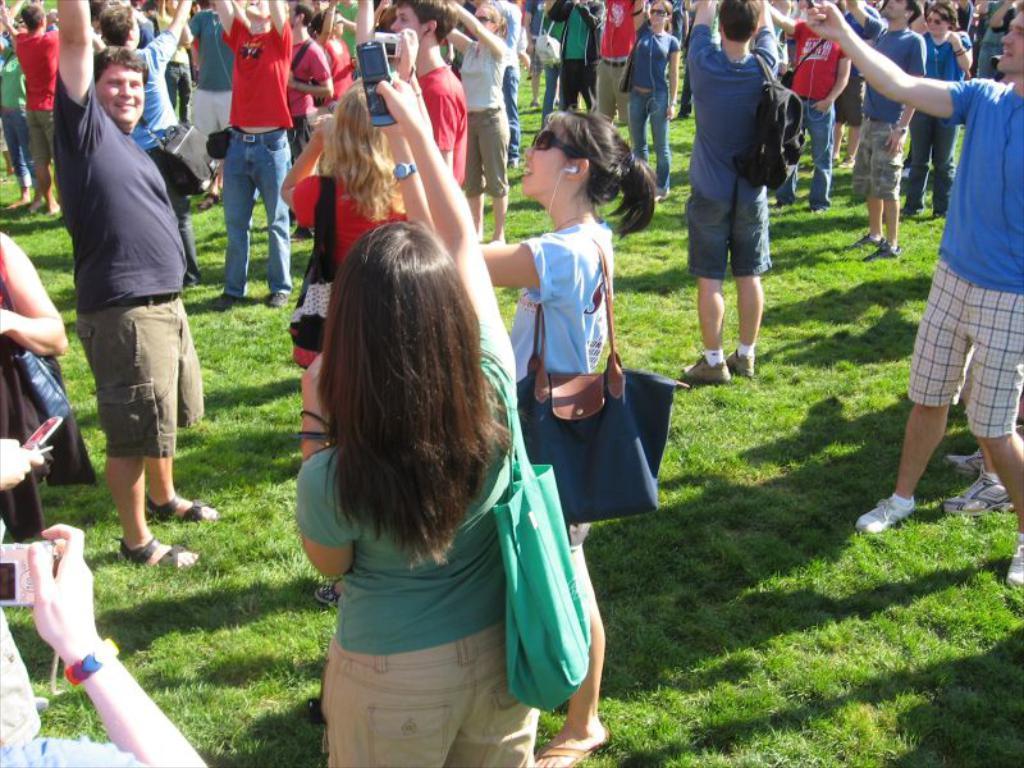How would you summarize this image in a sentence or two? In the center of the image there are people. At the bottom of the image there is grass. 